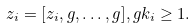Convert formula to latex. <formula><loc_0><loc_0><loc_500><loc_500>z _ { i } = [ z _ { i } , g , \dots , g ] , g k _ { i } \geq 1 .</formula> 